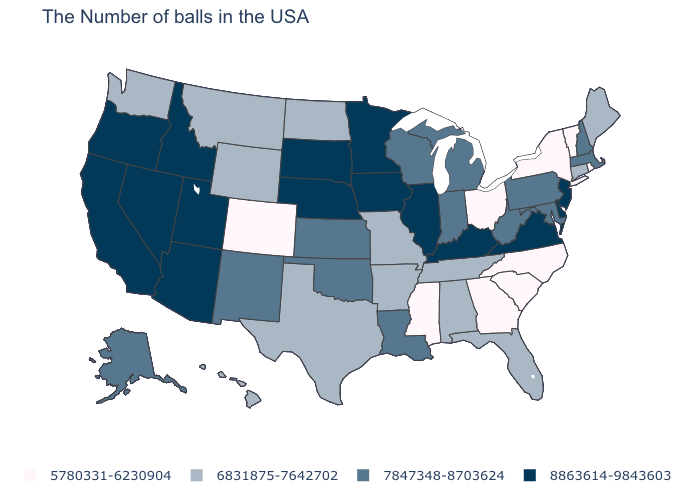Among the states that border Florida , does Georgia have the highest value?
Answer briefly. No. What is the value of Kentucky?
Quick response, please. 8863614-9843603. Which states have the lowest value in the USA?
Be succinct. Rhode Island, Vermont, New York, North Carolina, South Carolina, Ohio, Georgia, Mississippi, Colorado. What is the value of Alaska?
Concise answer only. 7847348-8703624. What is the value of Mississippi?
Keep it brief. 5780331-6230904. What is the highest value in the West ?
Keep it brief. 8863614-9843603. Among the states that border Michigan , does Ohio have the highest value?
Give a very brief answer. No. What is the value of New Jersey?
Quick response, please. 8863614-9843603. Does Texas have the lowest value in the USA?
Be succinct. No. Name the states that have a value in the range 6831875-7642702?
Keep it brief. Maine, Connecticut, Florida, Alabama, Tennessee, Missouri, Arkansas, Texas, North Dakota, Wyoming, Montana, Washington, Hawaii. What is the value of Vermont?
Short answer required. 5780331-6230904. Does the map have missing data?
Give a very brief answer. No. Name the states that have a value in the range 5780331-6230904?
Concise answer only. Rhode Island, Vermont, New York, North Carolina, South Carolina, Ohio, Georgia, Mississippi, Colorado. What is the highest value in the South ?
Concise answer only. 8863614-9843603. What is the value of Florida?
Give a very brief answer. 6831875-7642702. 